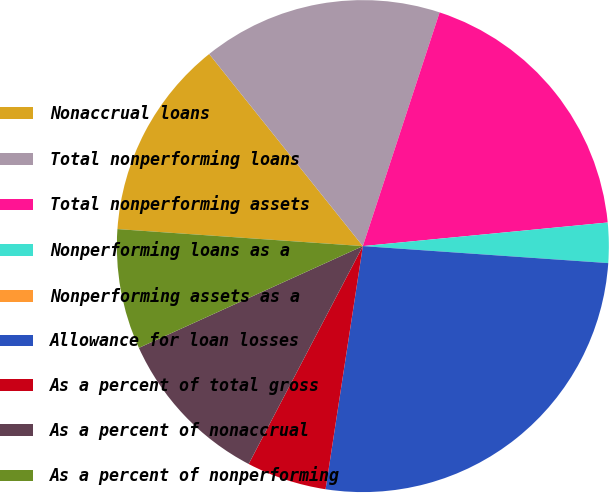Convert chart. <chart><loc_0><loc_0><loc_500><loc_500><pie_chart><fcel>Nonaccrual loans<fcel>Total nonperforming loans<fcel>Total nonperforming assets<fcel>Nonperforming loans as a<fcel>Nonperforming assets as a<fcel>Allowance for loan losses<fcel>As a percent of total gross<fcel>As a percent of nonaccrual<fcel>As a percent of nonperforming<nl><fcel>13.16%<fcel>15.79%<fcel>18.42%<fcel>2.63%<fcel>0.0%<fcel>26.32%<fcel>5.26%<fcel>10.53%<fcel>7.89%<nl></chart> 